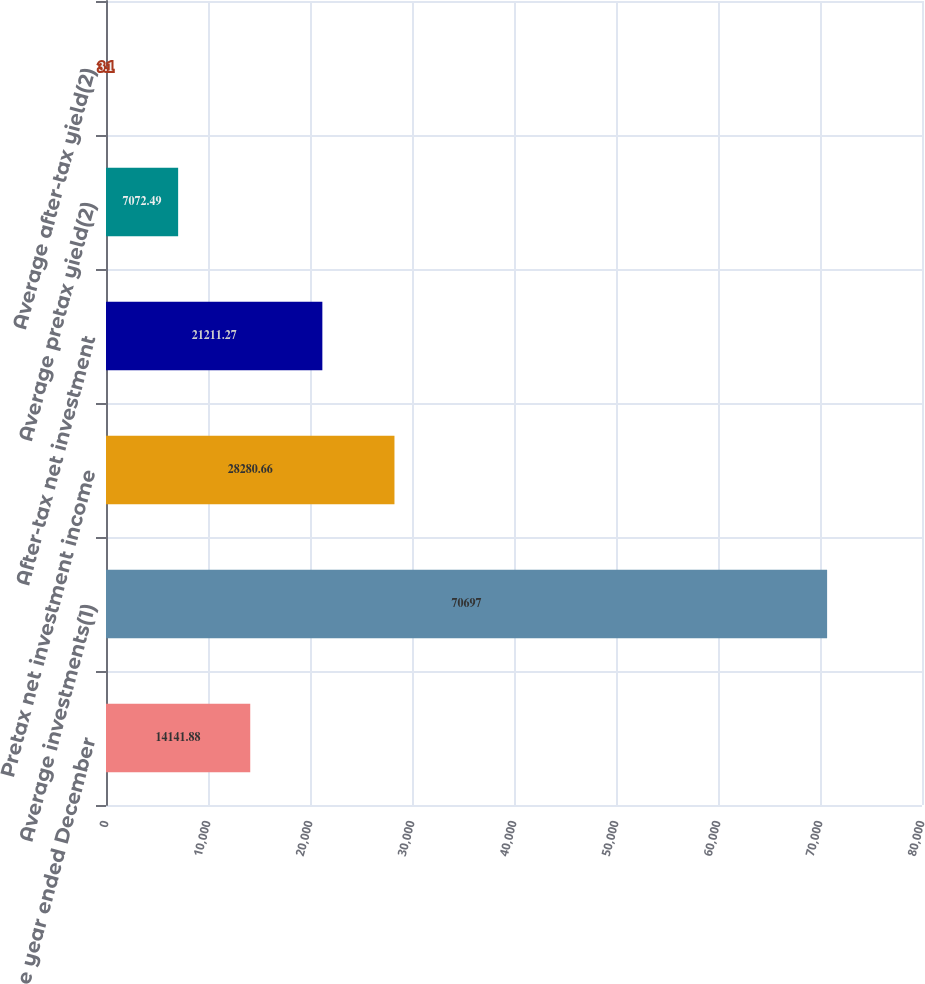Convert chart to OTSL. <chart><loc_0><loc_0><loc_500><loc_500><bar_chart><fcel>(for the year ended December<fcel>Average investments(1)<fcel>Pretax net investment income<fcel>After-tax net investment<fcel>Average pretax yield(2)<fcel>Average after-tax yield(2)<nl><fcel>14141.9<fcel>70697<fcel>28280.7<fcel>21211.3<fcel>7072.49<fcel>3.1<nl></chart> 